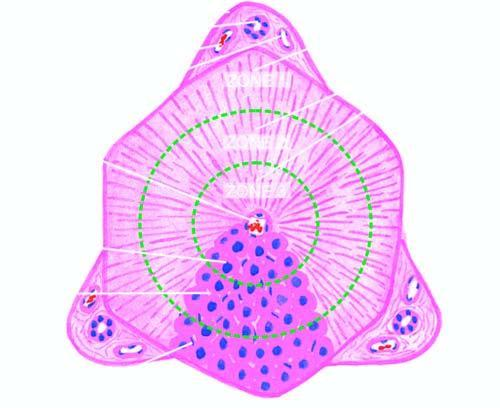what is the hexagonal or pyramidal structure with central vein and peripheral 4 to 5 portal triads termed?
Answer the question using a single word or phrase. Classical lobule 